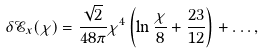Convert formula to latex. <formula><loc_0><loc_0><loc_500><loc_500>\delta \mathcal { E } _ { x } ( \chi ) = \frac { \sqrt { 2 } } { 4 8 \pi } \chi ^ { 4 } \left ( \ln \frac { \chi } { 8 } + \frac { 2 3 } { 1 2 } \right ) + \dots ,</formula> 